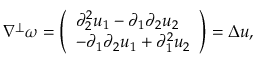<formula> <loc_0><loc_0><loc_500><loc_500>\begin{array} { r } { \nabla ^ { \perp } \omega = \left ( \begin{array} { l } { \partial _ { 2 } ^ { 2 } u _ { 1 } - \partial _ { 1 } \partial _ { 2 } u _ { 2 } } \\ { - \partial _ { 1 } \partial _ { 2 } u _ { 1 } + \partial _ { 1 } ^ { 2 } u _ { 2 } } \end{array} \right ) = \Delta u , } \end{array}</formula> 